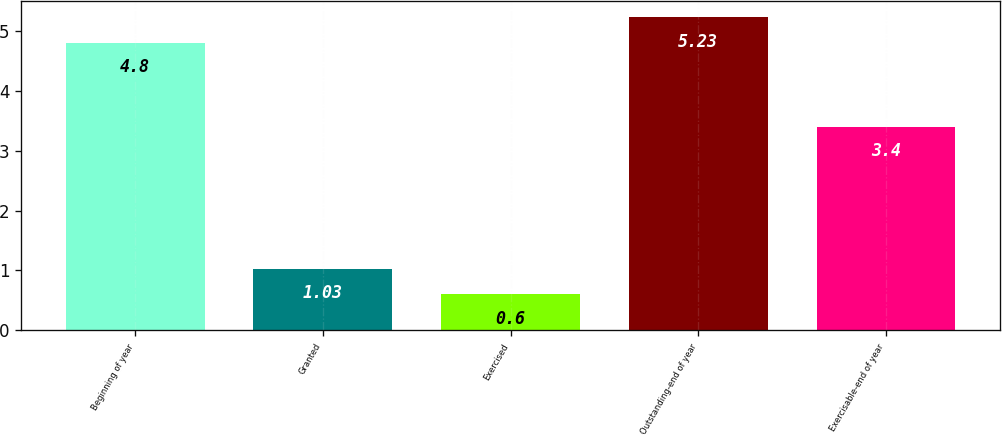Convert chart to OTSL. <chart><loc_0><loc_0><loc_500><loc_500><bar_chart><fcel>Beginning of year<fcel>Granted<fcel>Exercised<fcel>Outstanding-end of year<fcel>Exercisable-end of year<nl><fcel>4.8<fcel>1.03<fcel>0.6<fcel>5.23<fcel>3.4<nl></chart> 